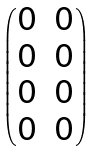<formula> <loc_0><loc_0><loc_500><loc_500>\begin{pmatrix} 0 & 0 \\ 0 & 0 \\ 0 & 0 \\ 0 & 0 \end{pmatrix}</formula> 